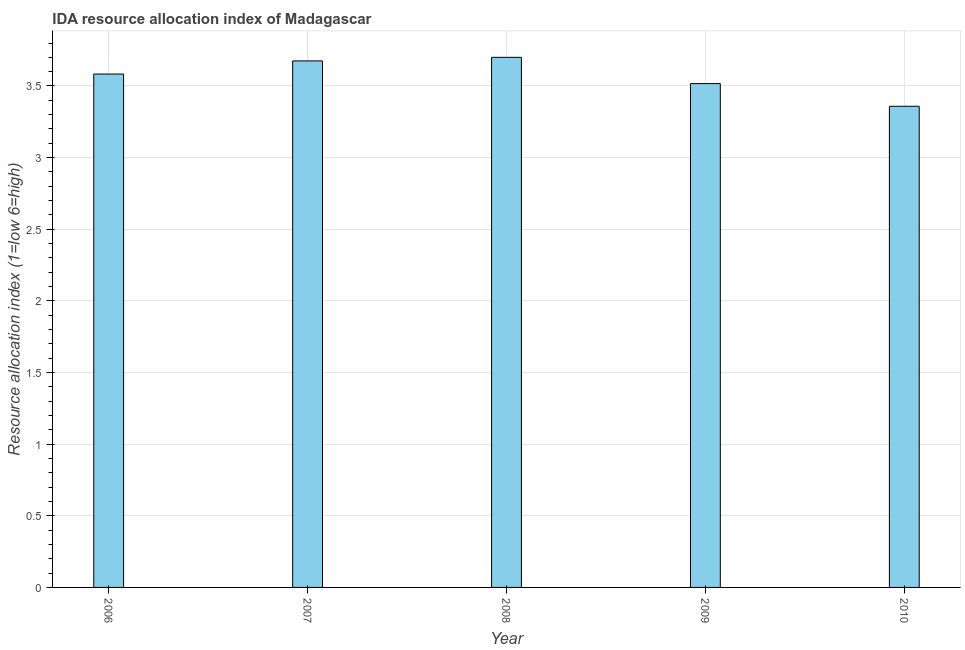Does the graph contain any zero values?
Give a very brief answer. No. What is the title of the graph?
Give a very brief answer. IDA resource allocation index of Madagascar. What is the label or title of the Y-axis?
Offer a very short reply. Resource allocation index (1=low 6=high). What is the ida resource allocation index in 2007?
Give a very brief answer. 3.67. Across all years, what is the maximum ida resource allocation index?
Ensure brevity in your answer.  3.7. Across all years, what is the minimum ida resource allocation index?
Your response must be concise. 3.36. In which year was the ida resource allocation index minimum?
Give a very brief answer. 2010. What is the sum of the ida resource allocation index?
Give a very brief answer. 17.83. What is the difference between the ida resource allocation index in 2006 and 2007?
Your answer should be compact. -0.09. What is the average ida resource allocation index per year?
Make the answer very short. 3.57. What is the median ida resource allocation index?
Provide a succinct answer. 3.58. In how many years, is the ida resource allocation index greater than 2.1 ?
Offer a terse response. 5. What is the ratio of the ida resource allocation index in 2007 to that in 2008?
Your response must be concise. 0.99. Is the ida resource allocation index in 2007 less than that in 2010?
Your answer should be very brief. No. What is the difference between the highest and the second highest ida resource allocation index?
Your answer should be very brief. 0.03. What is the difference between the highest and the lowest ida resource allocation index?
Your answer should be very brief. 0.34. Are all the bars in the graph horizontal?
Your answer should be compact. No. What is the difference between two consecutive major ticks on the Y-axis?
Ensure brevity in your answer.  0.5. What is the Resource allocation index (1=low 6=high) of 2006?
Provide a succinct answer. 3.58. What is the Resource allocation index (1=low 6=high) in 2007?
Give a very brief answer. 3.67. What is the Resource allocation index (1=low 6=high) of 2008?
Keep it short and to the point. 3.7. What is the Resource allocation index (1=low 6=high) of 2009?
Keep it short and to the point. 3.52. What is the Resource allocation index (1=low 6=high) of 2010?
Your answer should be compact. 3.36. What is the difference between the Resource allocation index (1=low 6=high) in 2006 and 2007?
Give a very brief answer. -0.09. What is the difference between the Resource allocation index (1=low 6=high) in 2006 and 2008?
Offer a very short reply. -0.12. What is the difference between the Resource allocation index (1=low 6=high) in 2006 and 2009?
Make the answer very short. 0.07. What is the difference between the Resource allocation index (1=low 6=high) in 2006 and 2010?
Offer a very short reply. 0.23. What is the difference between the Resource allocation index (1=low 6=high) in 2007 and 2008?
Provide a short and direct response. -0.03. What is the difference between the Resource allocation index (1=low 6=high) in 2007 and 2009?
Make the answer very short. 0.16. What is the difference between the Resource allocation index (1=low 6=high) in 2007 and 2010?
Give a very brief answer. 0.32. What is the difference between the Resource allocation index (1=low 6=high) in 2008 and 2009?
Provide a short and direct response. 0.18. What is the difference between the Resource allocation index (1=low 6=high) in 2008 and 2010?
Provide a succinct answer. 0.34. What is the difference between the Resource allocation index (1=low 6=high) in 2009 and 2010?
Your answer should be compact. 0.16. What is the ratio of the Resource allocation index (1=low 6=high) in 2006 to that in 2009?
Keep it short and to the point. 1.02. What is the ratio of the Resource allocation index (1=low 6=high) in 2006 to that in 2010?
Offer a very short reply. 1.07. What is the ratio of the Resource allocation index (1=low 6=high) in 2007 to that in 2008?
Provide a succinct answer. 0.99. What is the ratio of the Resource allocation index (1=low 6=high) in 2007 to that in 2009?
Provide a succinct answer. 1.04. What is the ratio of the Resource allocation index (1=low 6=high) in 2007 to that in 2010?
Make the answer very short. 1.09. What is the ratio of the Resource allocation index (1=low 6=high) in 2008 to that in 2009?
Ensure brevity in your answer.  1.05. What is the ratio of the Resource allocation index (1=low 6=high) in 2008 to that in 2010?
Make the answer very short. 1.1. What is the ratio of the Resource allocation index (1=low 6=high) in 2009 to that in 2010?
Your answer should be compact. 1.05. 